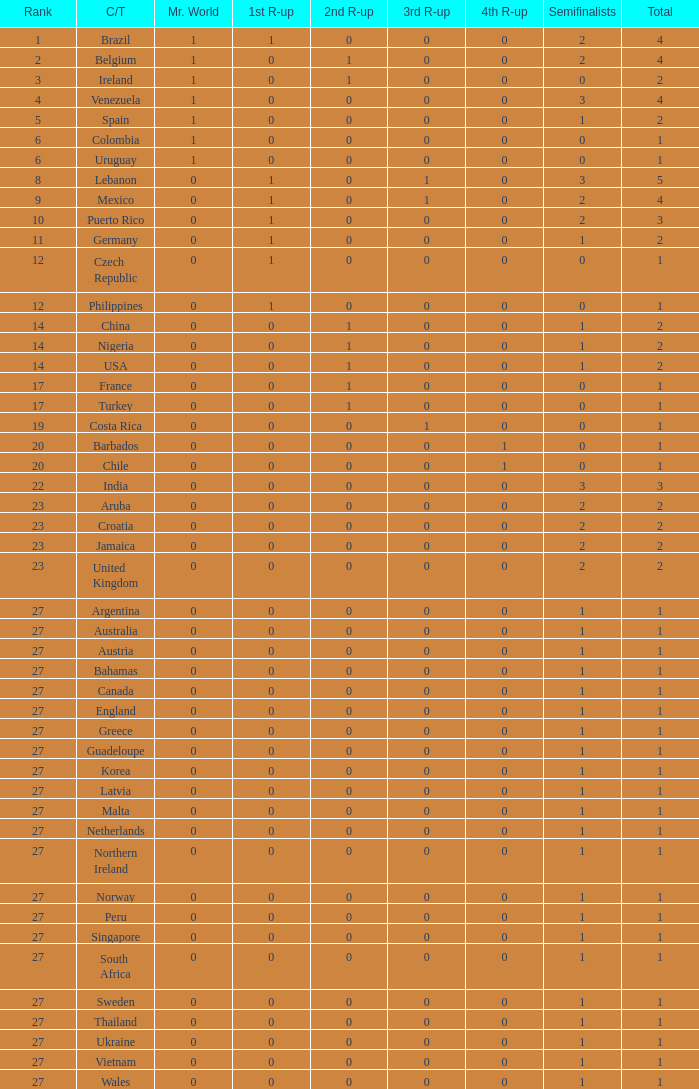What is the number of 1st runner up values for Jamaica? 1.0. 